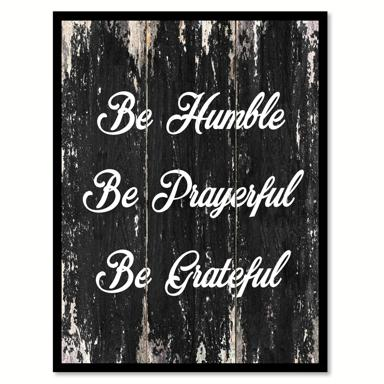How might these phrases impact someone's daily life if they applied them? Applying these phrases, 'Be Humble,' 'Be Prayerful,' and 'Be Grateful,' can lead to a more fulfilled and serene life. They encourage a positive outlook by fostering humility, spirituality, and thankfulness, which could improve one's interactions with others and overall well-being. Can these ideas be linked to any specific philosophical or religious teachings? Yes, these phrases broadly align with many philosophical and religious teachings. In Christianity, for instance, humility, prayer, and gratitude are central tenets. Similarly, many Eastern philosophies like Buddhism emphasize humility and a thankful approach to life as foundations for peace and enlightenment. 